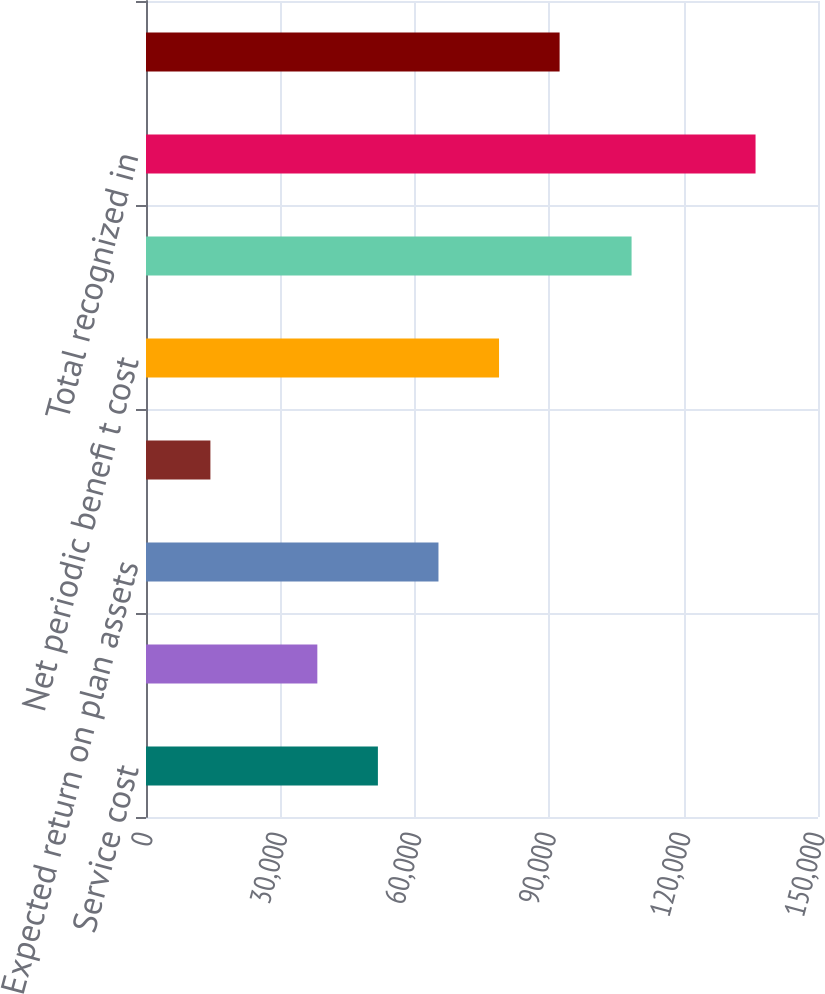Convert chart to OTSL. <chart><loc_0><loc_0><loc_500><loc_500><bar_chart><fcel>Service cost<fcel>Interest cost<fcel>Expected return on plan assets<fcel>Amortization of prior service<fcel>Net periodic benefi t cost<fcel>Net loss (gain)<fcel>Total recognized in<fcel>TOTAL RECOGNIZED IN NET<nl><fcel>51763.3<fcel>38243<fcel>65283.6<fcel>14376.3<fcel>78803.9<fcel>108387<fcel>136059<fcel>92324.2<nl></chart> 